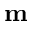<formula> <loc_0><loc_0><loc_500><loc_500>m</formula> 